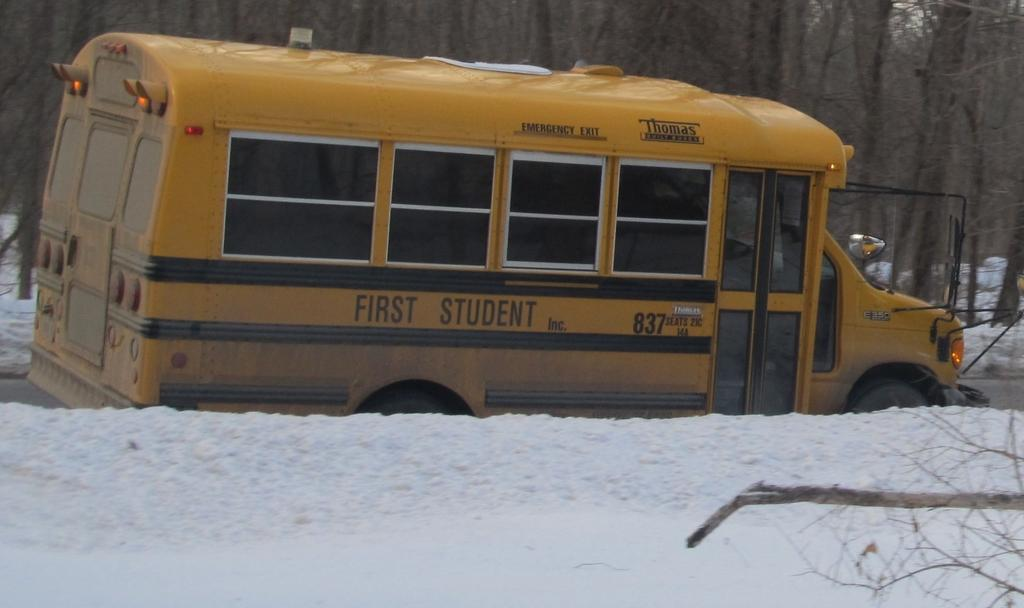<image>
Describe the image concisely. a bus with the words first student on it 